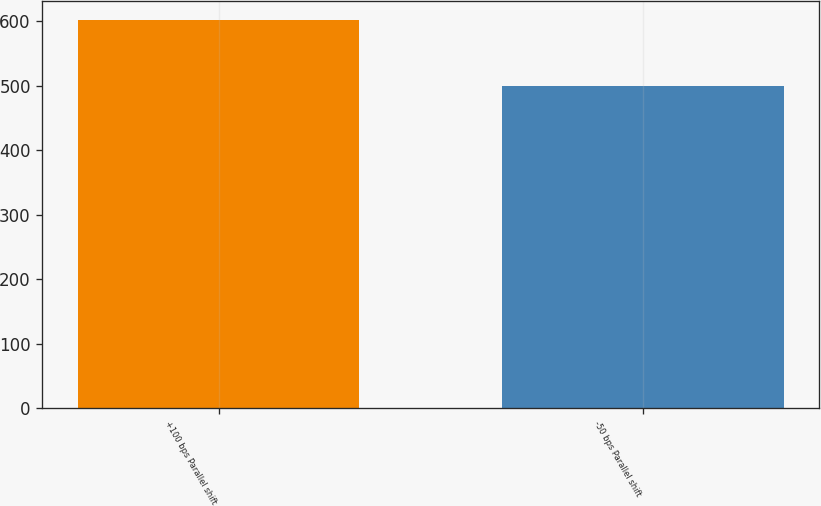<chart> <loc_0><loc_0><loc_500><loc_500><bar_chart><fcel>+100 bps Parallel shift<fcel>-50 bps Parallel shift<nl><fcel>601<fcel>499<nl></chart> 